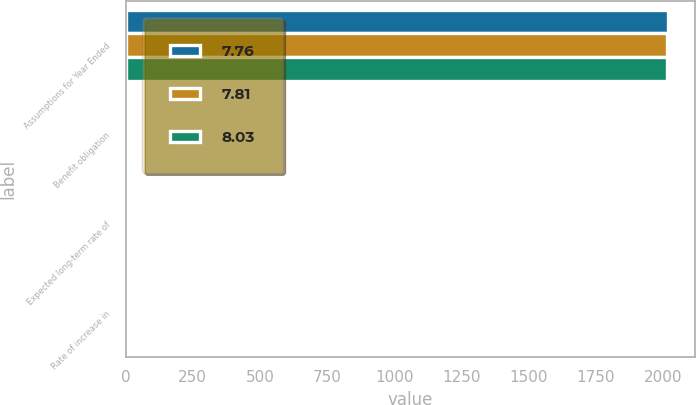Convert chart. <chart><loc_0><loc_0><loc_500><loc_500><stacked_bar_chart><ecel><fcel>Assumptions for Year Ended<fcel>Benefit obligation<fcel>Expected long-term rate of<fcel>Rate of increase in<nl><fcel>7.76<fcel>2017<fcel>4.19<fcel>7.43<fcel>2.9<nl><fcel>7.81<fcel>2016<fcel>4.46<fcel>8.14<fcel>3.39<nl><fcel>8.03<fcel>2015<fcel>4.1<fcel>8.15<fcel>3.43<nl></chart> 